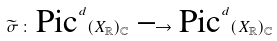<formula> <loc_0><loc_0><loc_500><loc_500>\widetilde { \sigma } \, \colon \, \text {Pic} ^ { d } ( X _ { \mathbb { R } } ) _ { \mathbb { C } } \, \longrightarrow \, \text {Pic} ^ { d } ( X _ { \mathbb { R } } ) _ { \mathbb { C } }</formula> 